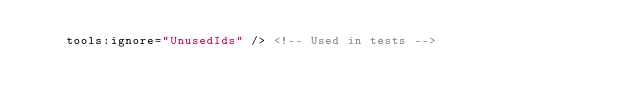Convert code to text. <code><loc_0><loc_0><loc_500><loc_500><_XML_>    tools:ignore="UnusedIds" /> <!-- Used in tests -->
</code> 